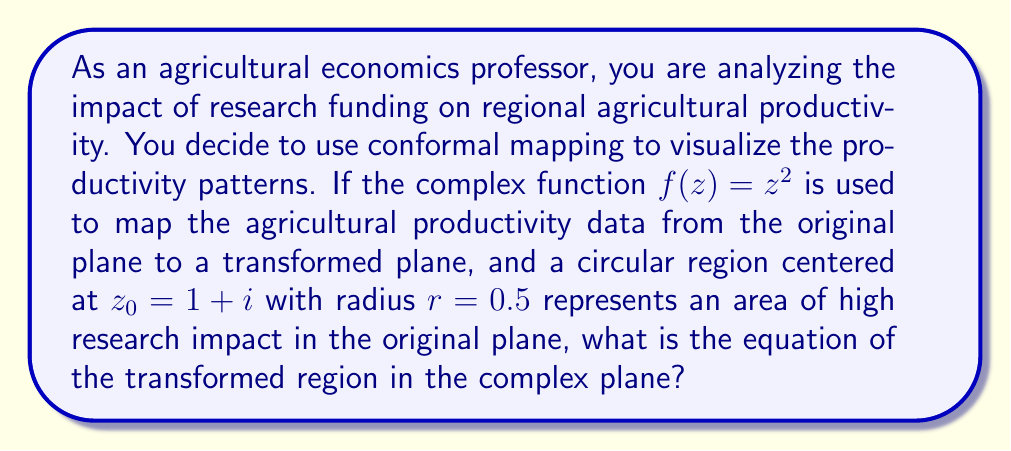Give your solution to this math problem. To solve this problem, we need to apply the conformal mapping $f(z) = z^2$ to the given circular region. Let's approach this step-by-step:

1) The original region is a circle centered at $z_0 = 1+i$ with radius $r=0.5$. We can represent any point on this circle as:

   $z = z_0 + re^{i\theta} = (1+i) + 0.5e^{i\theta}$, where $0 \leq \theta < 2\pi$

2) Now, we apply the transformation $f(z) = z^2$ to this circle:

   $f(z) = (z_0 + re^{i\theta})^2$

3) Let's expand this:
   
   $f(z) = (1+i + 0.5e^{i\theta})^2$
   
   $= (1+i)^2 + 2(1+i)(0.5e^{i\theta}) + (0.5e^{i\theta})^2$

4) Simplify:
   
   $(1+i)^2 = 1+2i-1 = 2i$
   
   $2(1+i)(0.5e^{i\theta}) = (1+i)e^{i\theta}$
   
   $(0.5e^{i\theta})^2 = 0.25e^{2i\theta}$

5) Substituting back:

   $f(z) = 2i + (1+i)e^{i\theta} + 0.25e^{2i\theta}$

6) This equation represents the transformed region in the complex plane. It's no longer a circle, but a more complex shape known as a limaçon.

7) To express this in a more standard form, we can separate the real and imaginary parts:

   $Re[f(z)] = \cos\theta + 0.25\cos(2\theta)$
   $Im[f(z)] = 2 + \sin\theta + 0.25\sin(2\theta)$

This parametric form represents the equation of the transformed region in the complex plane.
Answer: The equation of the transformed region in the complex plane is:

$f(z) = 2i + (1+i)e^{i\theta} + 0.25e^{2i\theta}$, where $0 \leq \theta < 2\pi$

Or in parametric form:
$Re[f(z)] = \cos\theta + 0.25\cos(2\theta)$
$Im[f(z)] = 2 + \sin\theta + 0.25\sin(2\theta)$ 